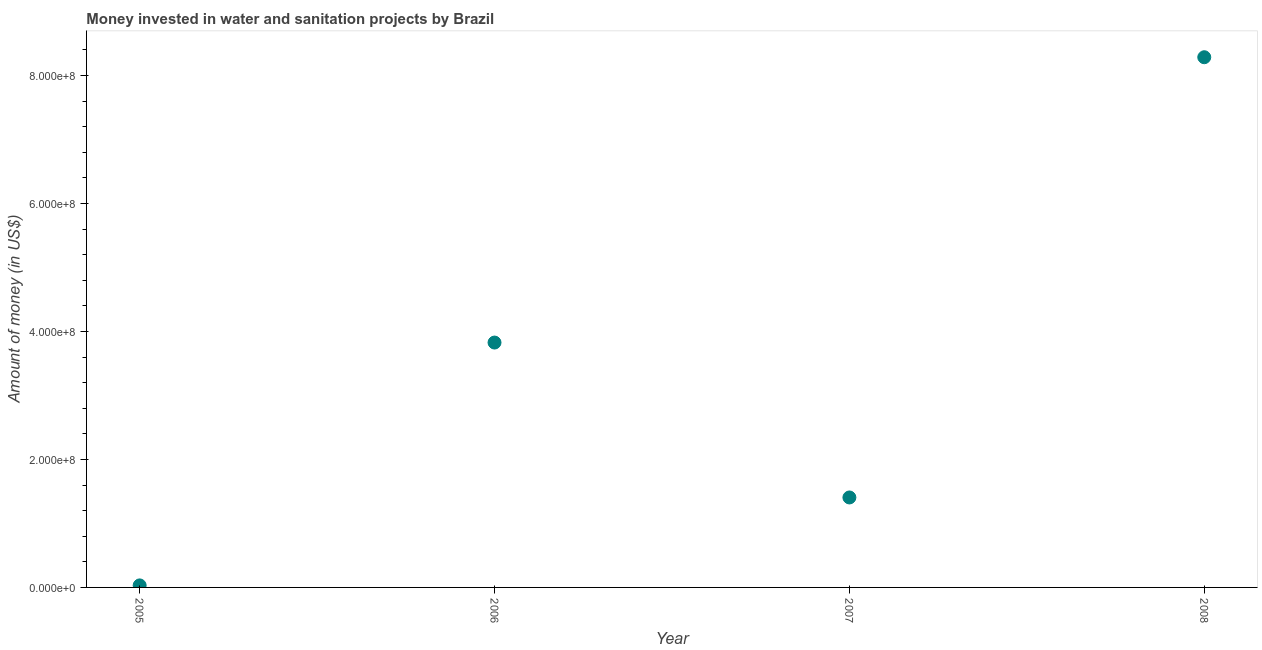What is the investment in 2008?
Give a very brief answer. 8.28e+08. Across all years, what is the maximum investment?
Your response must be concise. 8.28e+08. Across all years, what is the minimum investment?
Your answer should be compact. 3.16e+06. In which year was the investment maximum?
Offer a very short reply. 2008. In which year was the investment minimum?
Keep it short and to the point. 2005. What is the sum of the investment?
Offer a very short reply. 1.35e+09. What is the difference between the investment in 2005 and 2008?
Keep it short and to the point. -8.25e+08. What is the average investment per year?
Offer a terse response. 3.39e+08. What is the median investment?
Keep it short and to the point. 2.62e+08. In how many years, is the investment greater than 640000000 US$?
Offer a very short reply. 1. Do a majority of the years between 2006 and 2008 (inclusive) have investment greater than 200000000 US$?
Your answer should be compact. Yes. What is the ratio of the investment in 2005 to that in 2008?
Your response must be concise. 0. Is the difference between the investment in 2005 and 2006 greater than the difference between any two years?
Provide a succinct answer. No. What is the difference between the highest and the second highest investment?
Offer a very short reply. 4.46e+08. What is the difference between the highest and the lowest investment?
Provide a succinct answer. 8.25e+08. Does the investment monotonically increase over the years?
Your response must be concise. No. How many dotlines are there?
Your response must be concise. 1. Are the values on the major ticks of Y-axis written in scientific E-notation?
Ensure brevity in your answer.  Yes. What is the title of the graph?
Make the answer very short. Money invested in water and sanitation projects by Brazil. What is the label or title of the X-axis?
Keep it short and to the point. Year. What is the label or title of the Y-axis?
Make the answer very short. Amount of money (in US$). What is the Amount of money (in US$) in 2005?
Provide a succinct answer. 3.16e+06. What is the Amount of money (in US$) in 2006?
Offer a very short reply. 3.83e+08. What is the Amount of money (in US$) in 2007?
Provide a short and direct response. 1.41e+08. What is the Amount of money (in US$) in 2008?
Your response must be concise. 8.28e+08. What is the difference between the Amount of money (in US$) in 2005 and 2006?
Your answer should be compact. -3.79e+08. What is the difference between the Amount of money (in US$) in 2005 and 2007?
Your response must be concise. -1.37e+08. What is the difference between the Amount of money (in US$) in 2005 and 2008?
Provide a short and direct response. -8.25e+08. What is the difference between the Amount of money (in US$) in 2006 and 2007?
Offer a very short reply. 2.42e+08. What is the difference between the Amount of money (in US$) in 2006 and 2008?
Give a very brief answer. -4.46e+08. What is the difference between the Amount of money (in US$) in 2007 and 2008?
Your answer should be compact. -6.88e+08. What is the ratio of the Amount of money (in US$) in 2005 to that in 2006?
Provide a short and direct response. 0.01. What is the ratio of the Amount of money (in US$) in 2005 to that in 2007?
Make the answer very short. 0.02. What is the ratio of the Amount of money (in US$) in 2005 to that in 2008?
Offer a terse response. 0. What is the ratio of the Amount of money (in US$) in 2006 to that in 2007?
Offer a terse response. 2.72. What is the ratio of the Amount of money (in US$) in 2006 to that in 2008?
Offer a terse response. 0.46. What is the ratio of the Amount of money (in US$) in 2007 to that in 2008?
Keep it short and to the point. 0.17. 